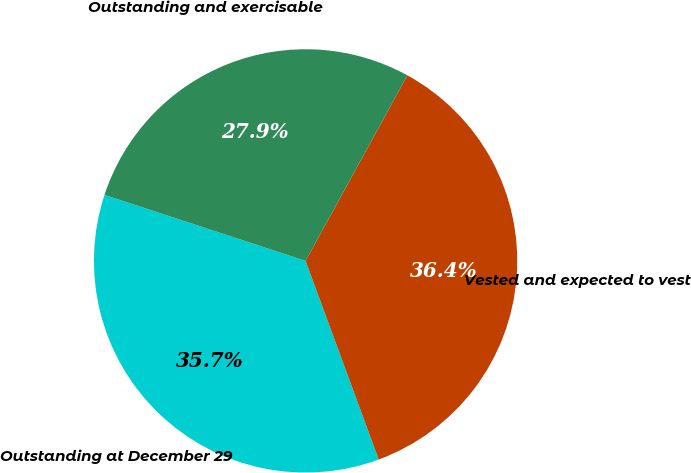<chart> <loc_0><loc_0><loc_500><loc_500><pie_chart><fcel>Outstanding at December 29<fcel>Vested and expected to vest<fcel>Outstanding and exercisable<nl><fcel>35.66%<fcel>36.4%<fcel>27.94%<nl></chart> 